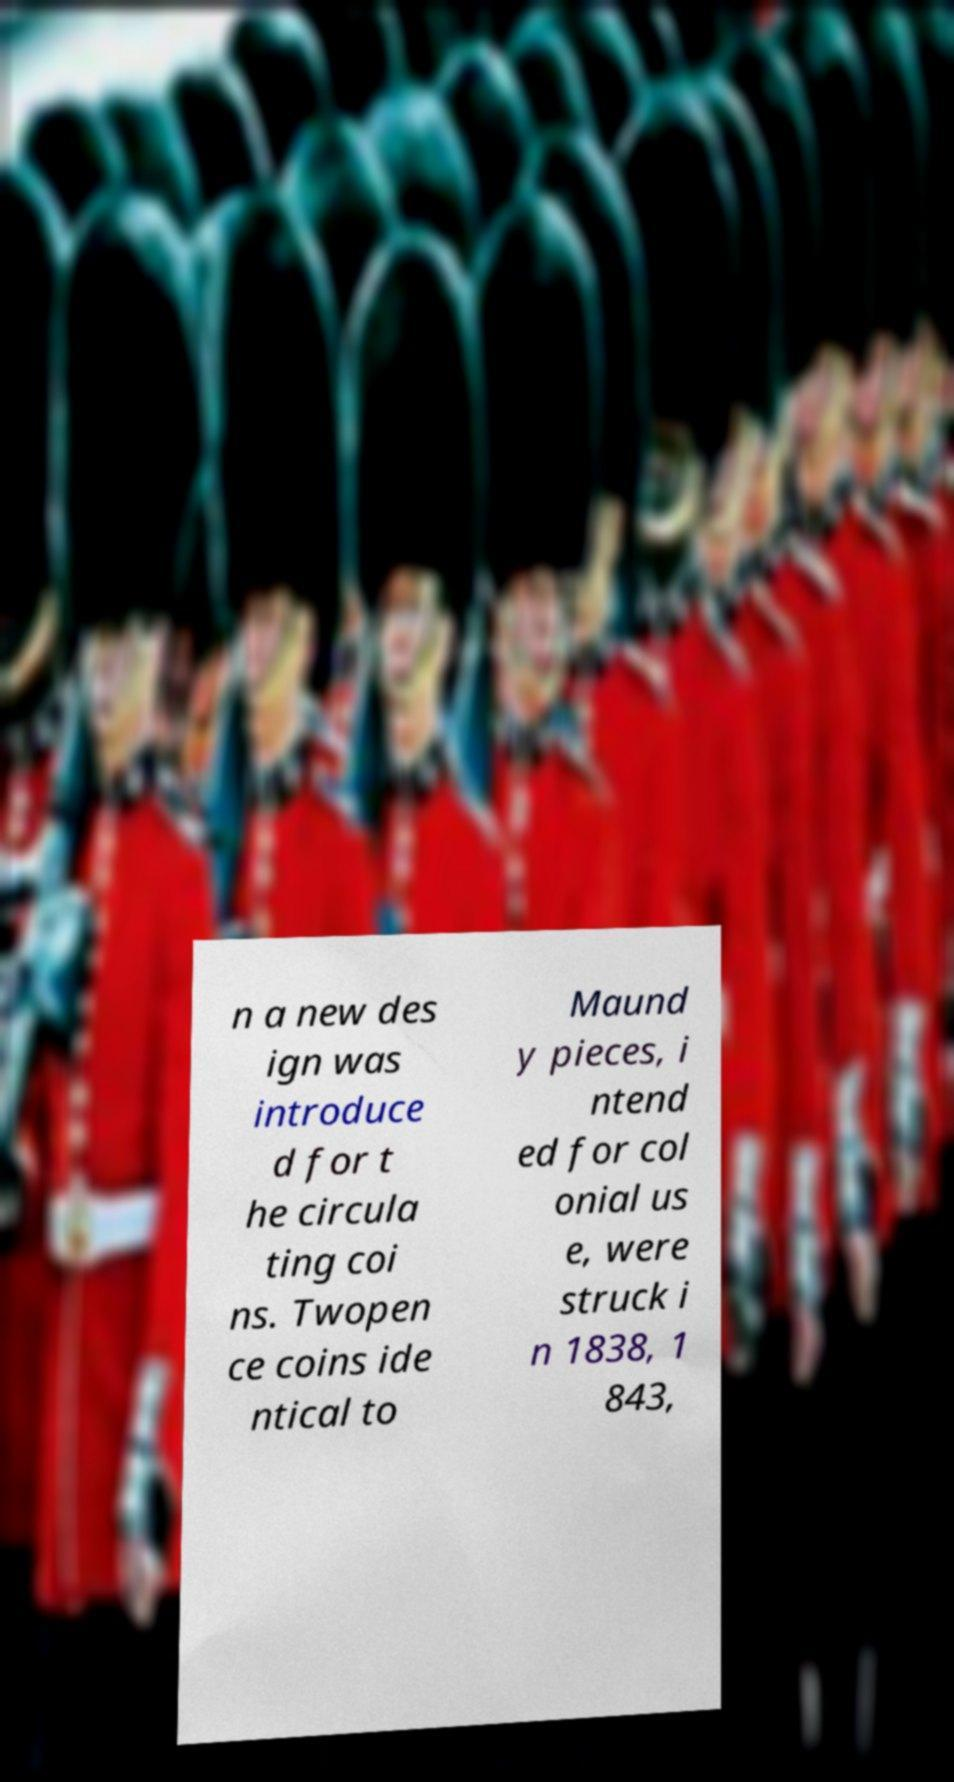There's text embedded in this image that I need extracted. Can you transcribe it verbatim? n a new des ign was introduce d for t he circula ting coi ns. Twopen ce coins ide ntical to Maund y pieces, i ntend ed for col onial us e, were struck i n 1838, 1 843, 